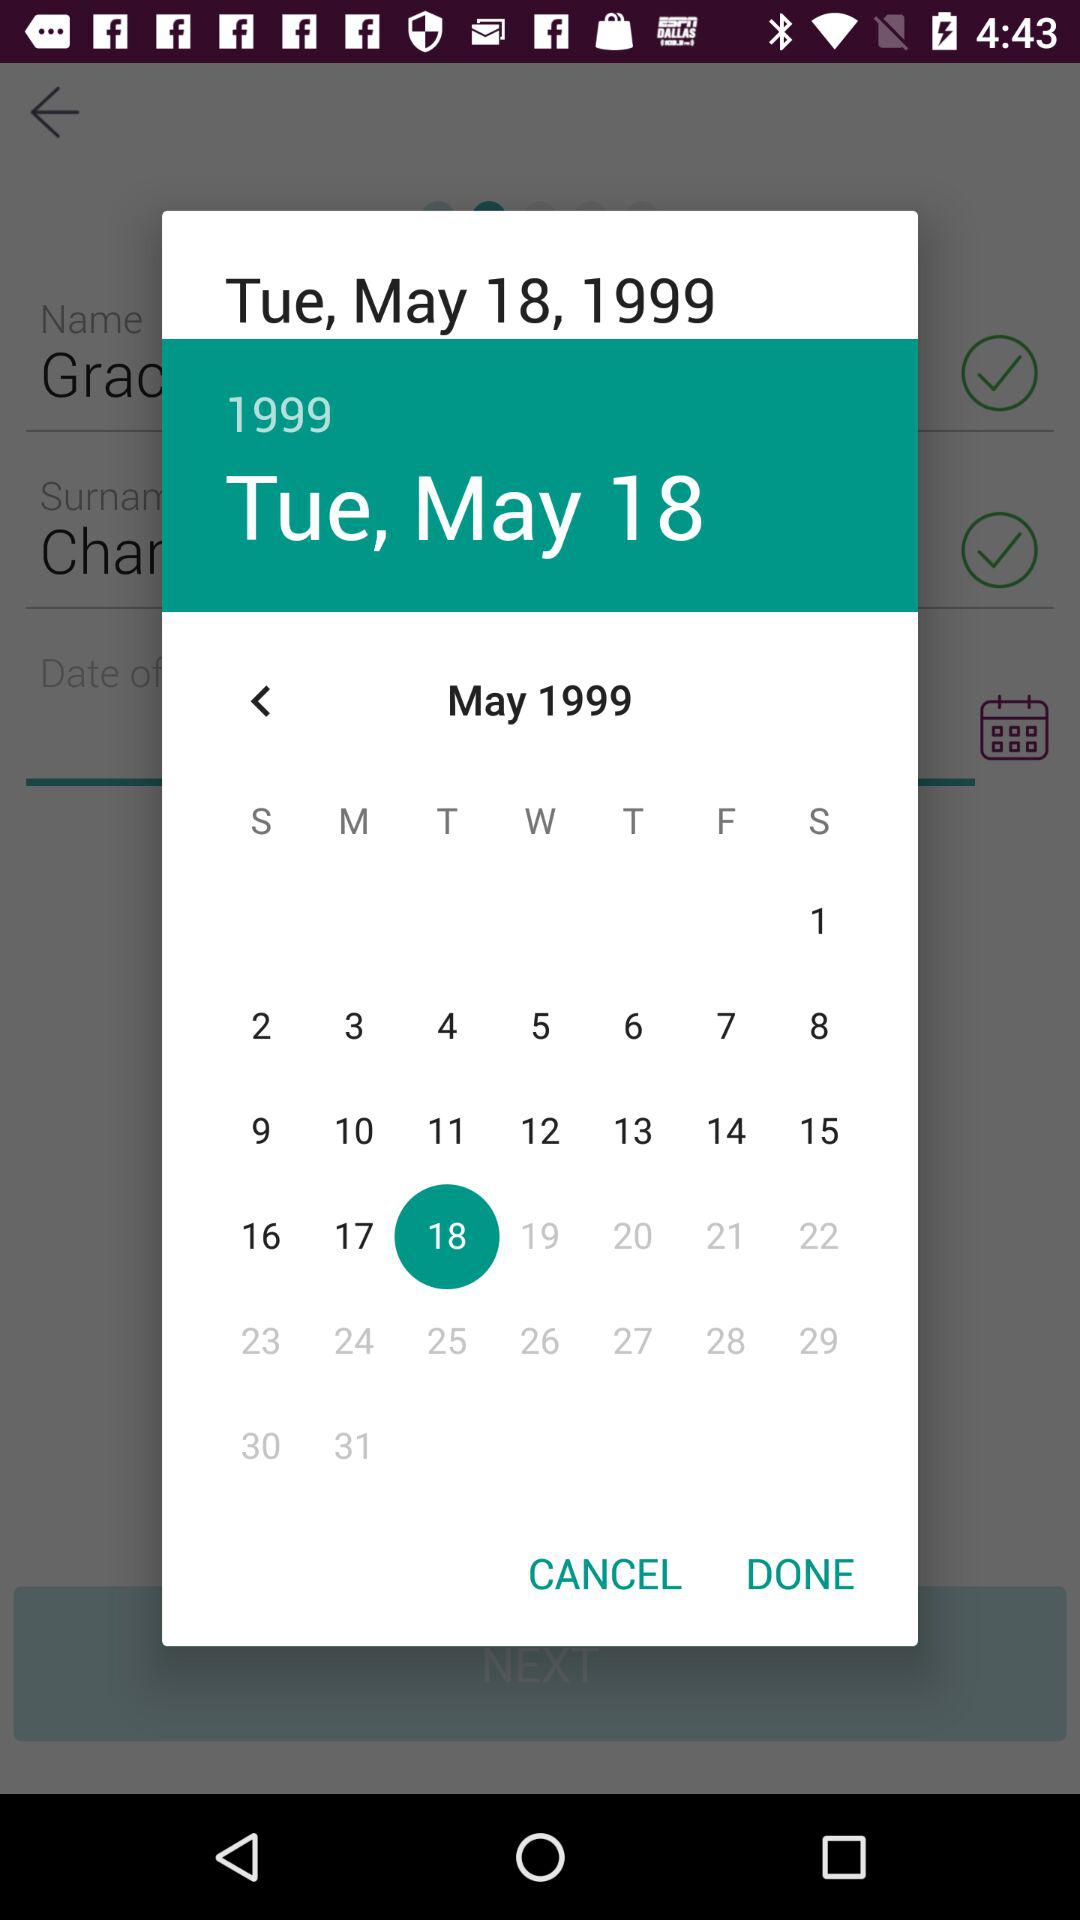Which month of the calendar is given? The given month is May. 